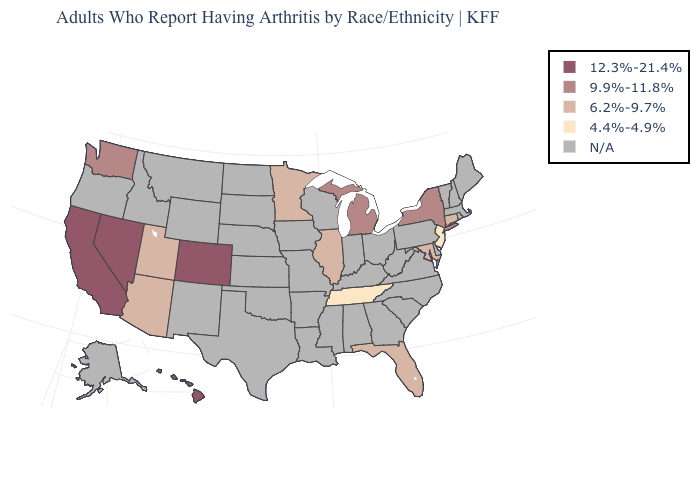How many symbols are there in the legend?
Write a very short answer. 5. What is the value of Minnesota?
Short answer required. 6.2%-9.7%. What is the value of Indiana?
Keep it brief. N/A. Name the states that have a value in the range N/A?
Be succinct. Alabama, Alaska, Arkansas, Delaware, Georgia, Idaho, Indiana, Iowa, Kansas, Kentucky, Louisiana, Maine, Massachusetts, Mississippi, Missouri, Montana, Nebraska, New Hampshire, New Mexico, North Carolina, North Dakota, Ohio, Oklahoma, Oregon, Pennsylvania, Rhode Island, South Carolina, South Dakota, Texas, Vermont, Virginia, West Virginia, Wisconsin, Wyoming. Which states have the highest value in the USA?
Write a very short answer. California, Colorado, Hawaii, Nevada. Which states hav the highest value in the South?
Quick response, please. Florida, Maryland. Name the states that have a value in the range N/A?
Answer briefly. Alabama, Alaska, Arkansas, Delaware, Georgia, Idaho, Indiana, Iowa, Kansas, Kentucky, Louisiana, Maine, Massachusetts, Mississippi, Missouri, Montana, Nebraska, New Hampshire, New Mexico, North Carolina, North Dakota, Ohio, Oklahoma, Oregon, Pennsylvania, Rhode Island, South Carolina, South Dakota, Texas, Vermont, Virginia, West Virginia, Wisconsin, Wyoming. Name the states that have a value in the range 4.4%-4.9%?
Keep it brief. New Jersey, Tennessee. What is the value of Michigan?
Concise answer only. 9.9%-11.8%. Name the states that have a value in the range 12.3%-21.4%?
Concise answer only. California, Colorado, Hawaii, Nevada. Does the first symbol in the legend represent the smallest category?
Answer briefly. No. What is the highest value in the MidWest ?
Be succinct. 9.9%-11.8%. 